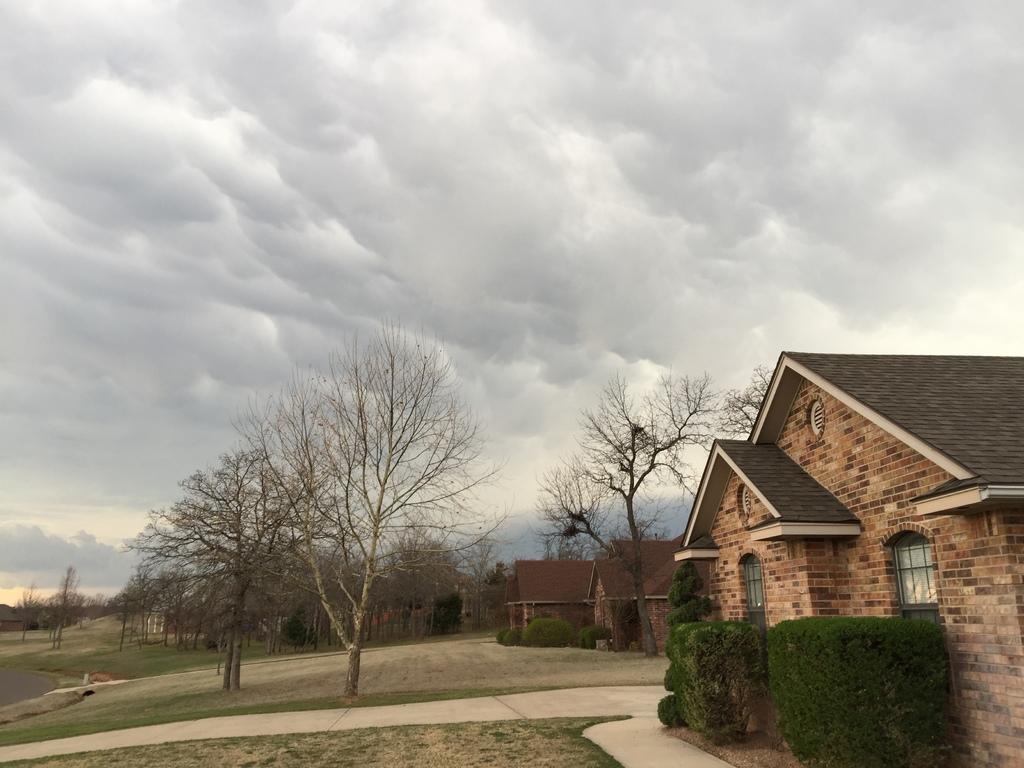How would you summarize this image in a sentence or two? On the right side of the image there are buildings and in front of the buildings there are plants. On the left side of the image there is a road. In the background of the image there are trees and sky. 